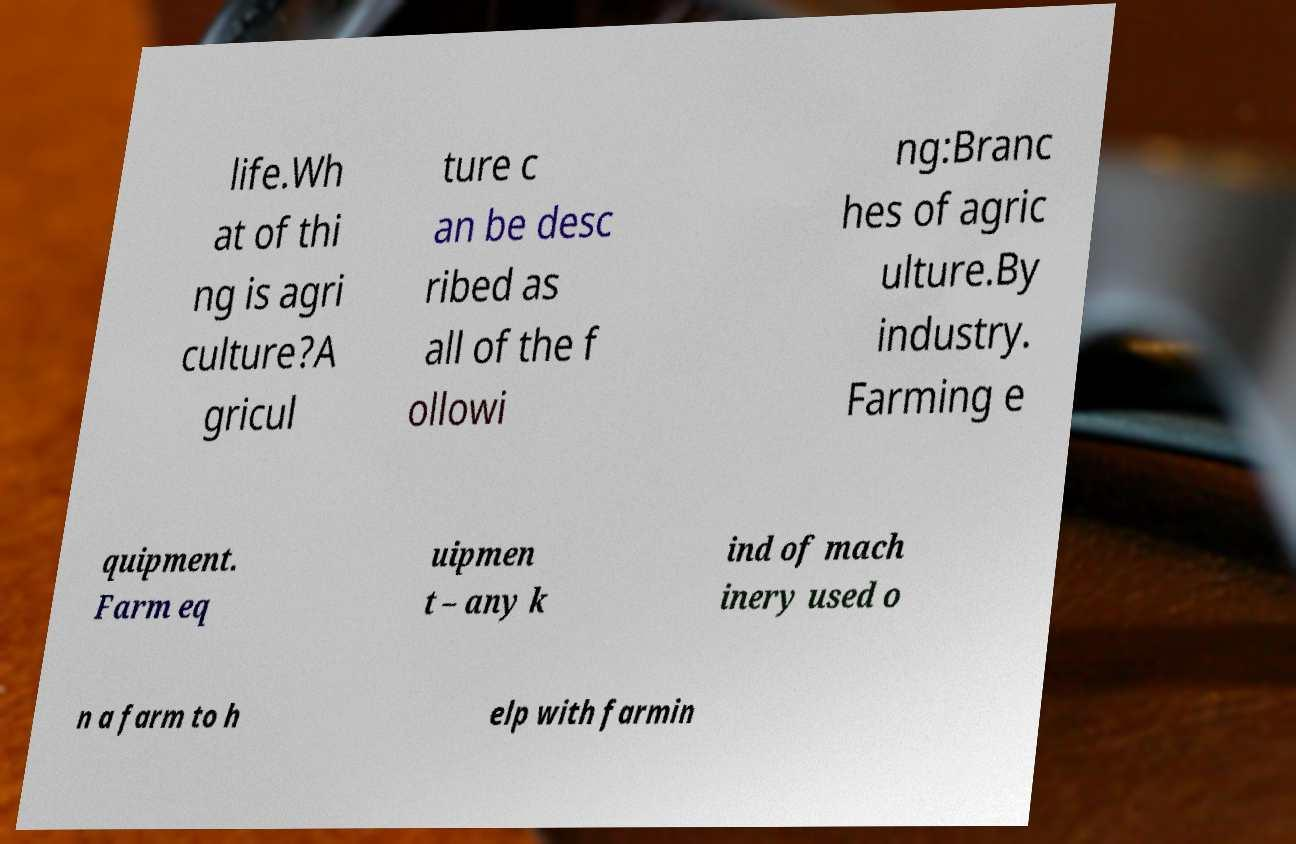For documentation purposes, I need the text within this image transcribed. Could you provide that? life.Wh at of thi ng is agri culture?A gricul ture c an be desc ribed as all of the f ollowi ng:Branc hes of agric ulture.By industry. Farming e quipment. Farm eq uipmen t – any k ind of mach inery used o n a farm to h elp with farmin 